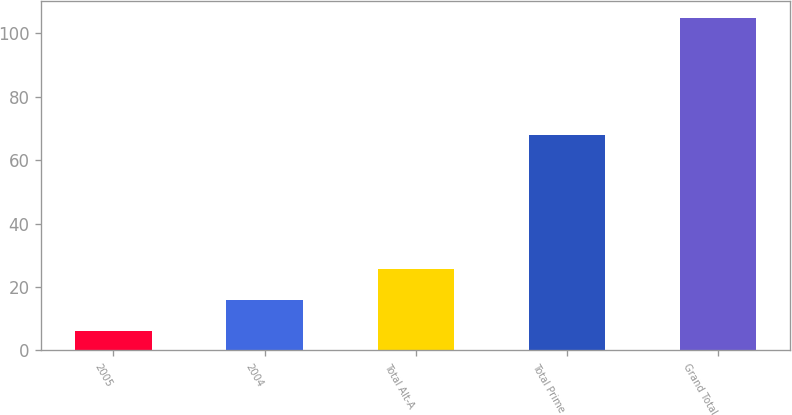Convert chart to OTSL. <chart><loc_0><loc_0><loc_500><loc_500><bar_chart><fcel>2005<fcel>2004<fcel>Total Alt-A<fcel>Total Prime<fcel>Grand Total<nl><fcel>6<fcel>15.9<fcel>25.8<fcel>68<fcel>105<nl></chart> 